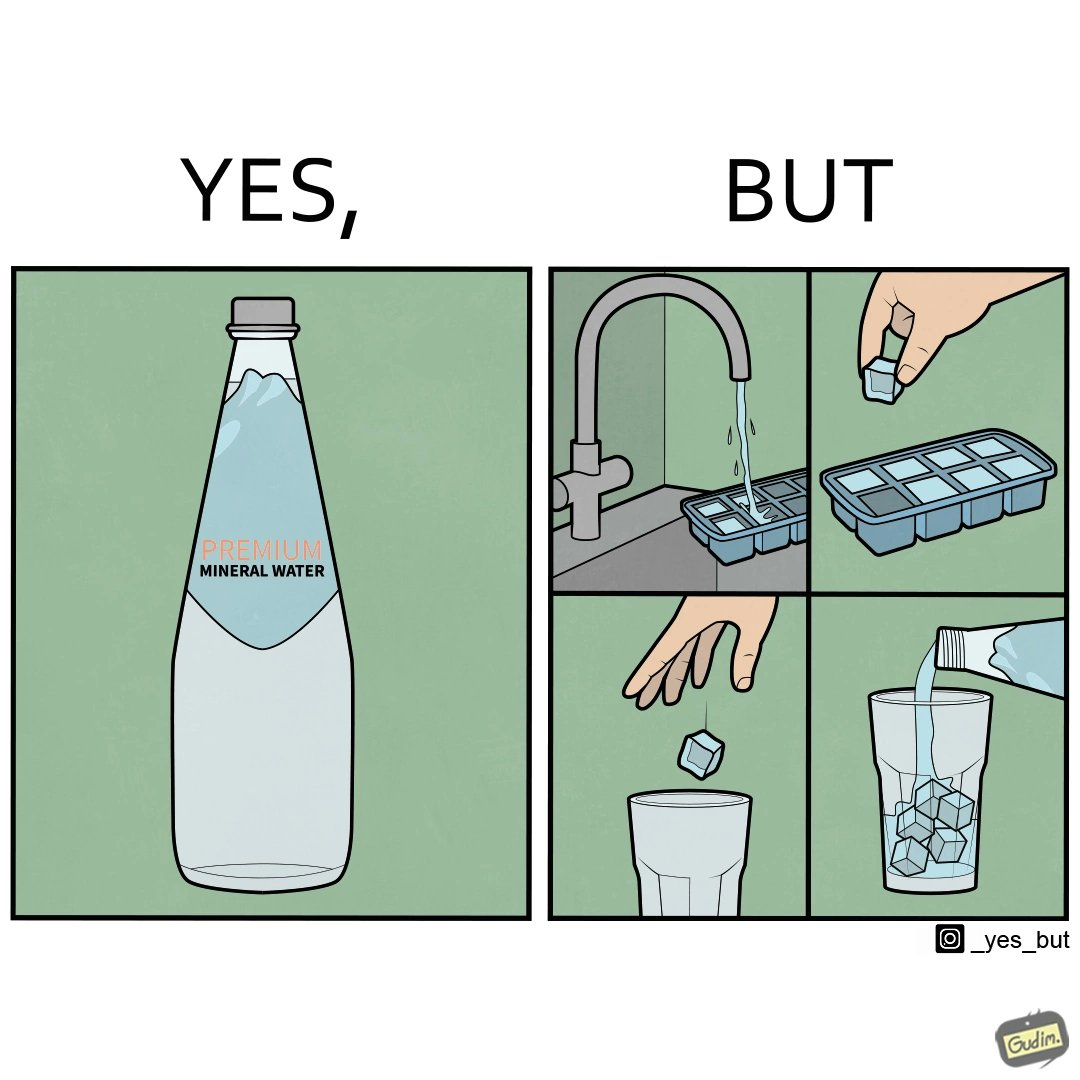What is shown in the left half versus the right half of this image? In the left part of the image: A bottle of "Premium Mineral Water". In the right part of the image: Pouring a bottle of water into a glass having ice cubes formed by refrigerating tap water. 